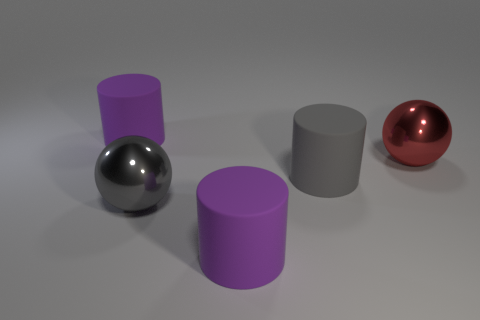Subtract all purple cylinders. How many cylinders are left? 1 Subtract all gray cylinders. How many cylinders are left? 2 Add 3 large gray spheres. How many objects exist? 8 Subtract all gray cylinders. Subtract all yellow balls. How many cylinders are left? 2 Subtract all yellow cylinders. How many red balls are left? 1 Subtract all big gray cylinders. Subtract all cyan rubber things. How many objects are left? 4 Add 1 red spheres. How many red spheres are left? 2 Add 3 large gray rubber objects. How many large gray rubber objects exist? 4 Subtract 0 gray cubes. How many objects are left? 5 Subtract all balls. How many objects are left? 3 